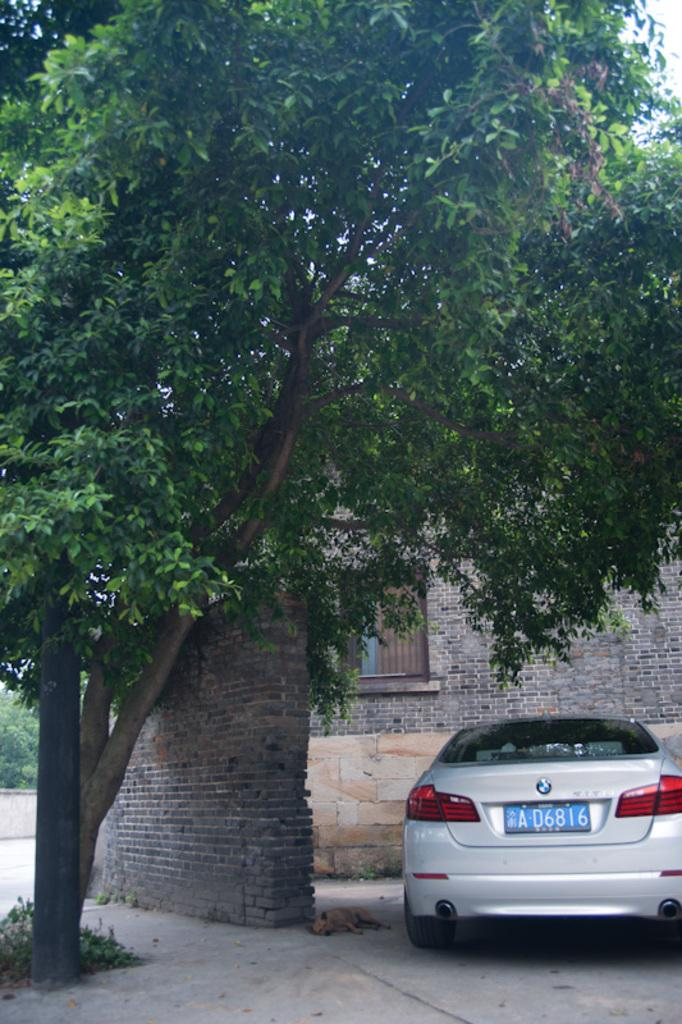What vehicle is located on the right side bottom of the image? There is a car on the right side bottom of the image. What animal can be seen on the path in the image? There is a dog on the path in the image. What type of vegetation is present in the image? Trees, plants, and a brick wall are present in the image. What structures can be seen in the image? Poles and a window are visible in the image. Can you tell me how many snakes are slithering around the car in the image? There are no snakes present in the image; it features a car, a dog, trees, plants, poles, and a window. Who is the expert in the image? There is no expert present in the image. Who is the partner of the dog in the image? There is no partner mentioned or depicted in the image; it only shows a dog on the path. 